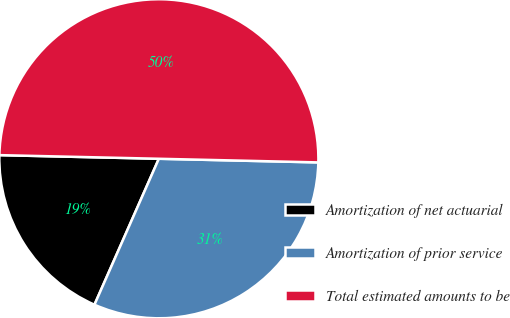Convert chart. <chart><loc_0><loc_0><loc_500><loc_500><pie_chart><fcel>Amortization of net actuarial<fcel>Amortization of prior service<fcel>Total estimated amounts to be<nl><fcel>18.75%<fcel>31.25%<fcel>50.0%<nl></chart> 